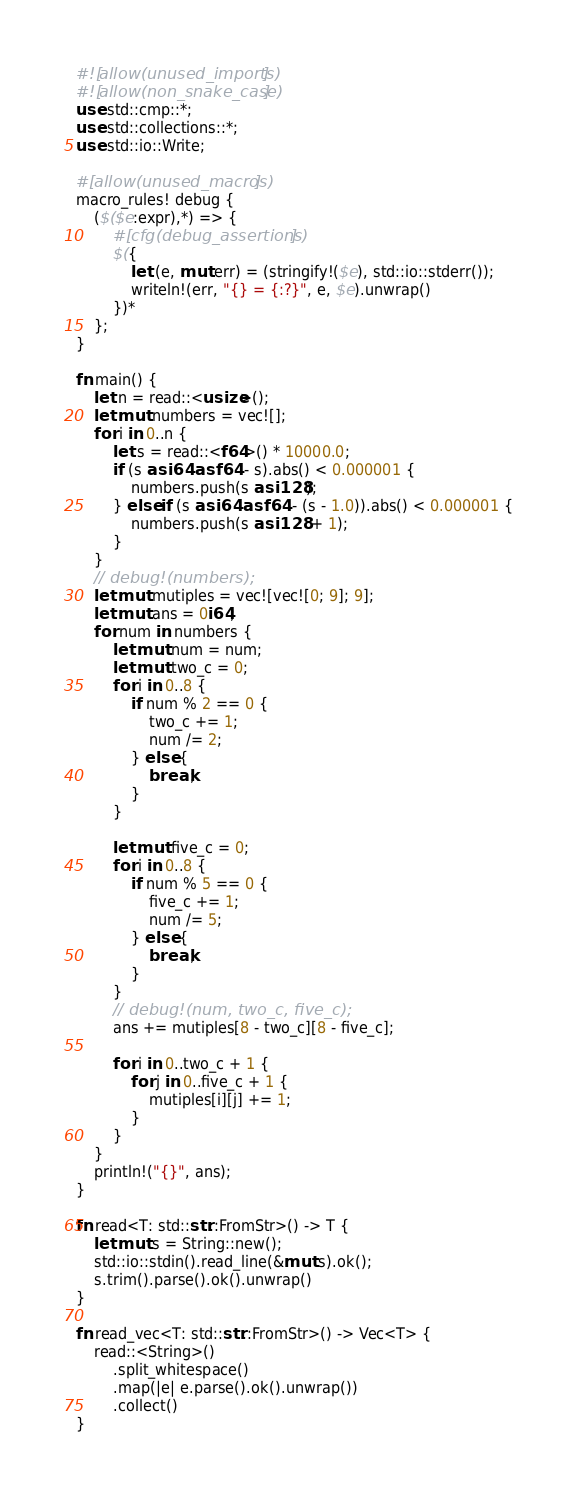<code> <loc_0><loc_0><loc_500><loc_500><_Rust_>#![allow(unused_imports)]
#![allow(non_snake_case)]
use std::cmp::*;
use std::collections::*;
use std::io::Write;

#[allow(unused_macros)]
macro_rules! debug {
    ($($e:expr),*) => {
        #[cfg(debug_assertions)]
        $({
            let (e, mut err) = (stringify!($e), std::io::stderr());
            writeln!(err, "{} = {:?}", e, $e).unwrap()
        })*
    };
}

fn main() {
    let n = read::<usize>();
    let mut numbers = vec![];
    for i in 0..n {
        let s = read::<f64>() * 10000.0;
        if (s as i64 as f64 - s).abs() < 0.000001 {
            numbers.push(s as i128);
        } else if (s as i64 as f64 - (s - 1.0)).abs() < 0.000001 {
            numbers.push(s as i128 + 1);
        }
    }
    // debug!(numbers);
    let mut mutiples = vec![vec![0; 9]; 9];
    let mut ans = 0i64;
    for num in numbers {
        let mut num = num;
        let mut two_c = 0;
        for i in 0..8 {
            if num % 2 == 0 {
                two_c += 1;
                num /= 2;
            } else {
                break;
            }
        }

        let mut five_c = 0;
        for i in 0..8 {
            if num % 5 == 0 {
                five_c += 1;
                num /= 5;
            } else {
                break;
            }
        }
        // debug!(num, two_c, five_c);
        ans += mutiples[8 - two_c][8 - five_c];

        for i in 0..two_c + 1 {
            for j in 0..five_c + 1 {
                mutiples[i][j] += 1;
            }
        }
    }
    println!("{}", ans);
}

fn read<T: std::str::FromStr>() -> T {
    let mut s = String::new();
    std::io::stdin().read_line(&mut s).ok();
    s.trim().parse().ok().unwrap()
}

fn read_vec<T: std::str::FromStr>() -> Vec<T> {
    read::<String>()
        .split_whitespace()
        .map(|e| e.parse().ok().unwrap())
        .collect()
}
</code> 